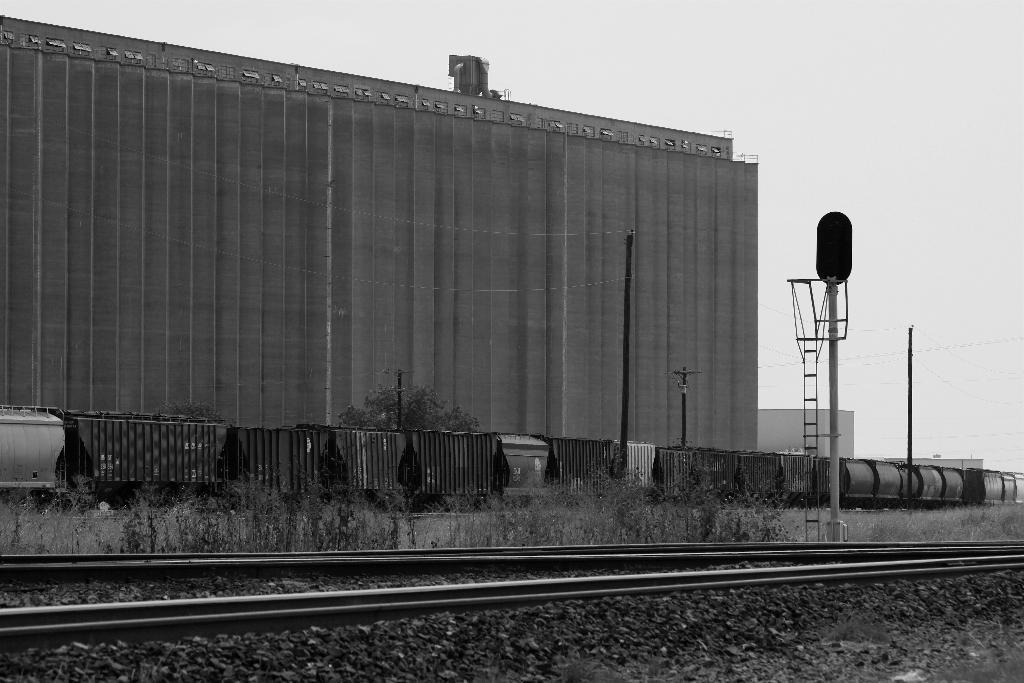Could you give a brief overview of what you see in this image? In this image in front there is a railway track. There is a board. There are poles. In the center of the image there is a train. There is a metal fence. In the background of the image there are buildings and sky. 